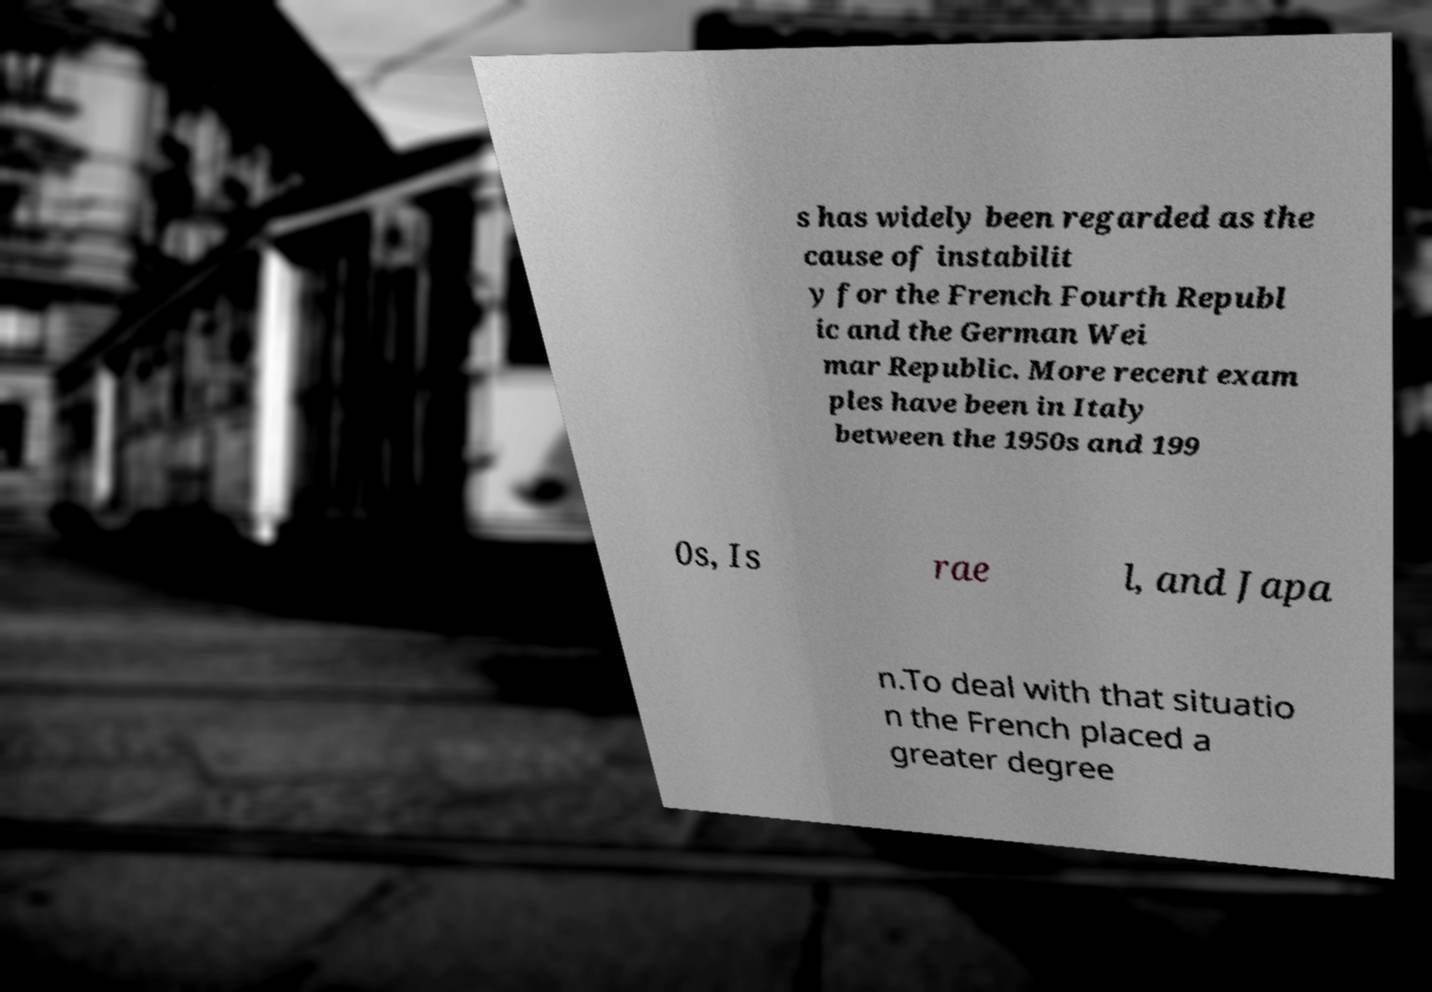Could you extract and type out the text from this image? s has widely been regarded as the cause of instabilit y for the French Fourth Republ ic and the German Wei mar Republic. More recent exam ples have been in Italy between the 1950s and 199 0s, Is rae l, and Japa n.To deal with that situatio n the French placed a greater degree 